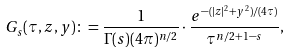Convert formula to latex. <formula><loc_0><loc_0><loc_500><loc_500>G _ { s } ( \tau , z , y ) \colon = \frac { 1 } { \Gamma ( s ) ( 4 \pi ) ^ { n / 2 } } \cdot \frac { e ^ { - ( | z | ^ { 2 } + y ^ { 2 } ) / ( 4 \tau ) } } { \tau ^ { n / 2 + 1 - s } } ,</formula> 